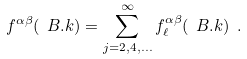<formula> <loc_0><loc_0><loc_500><loc_500>f ^ { \alpha \beta } ( \ B . k ) = \sum _ { j = 2 , 4 , \dots } ^ { \infty } f ^ { \alpha \beta } _ { \ell } ( \ B . k ) \ .</formula> 